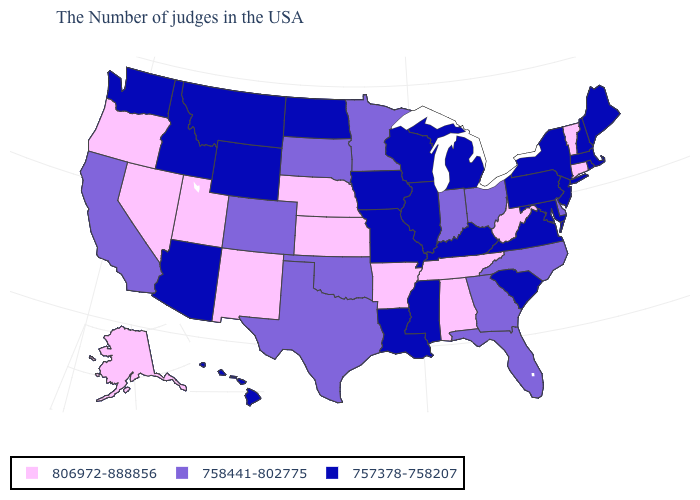Among the states that border Illinois , which have the highest value?
Quick response, please. Indiana. Among the states that border West Virginia , does Ohio have the highest value?
Quick response, please. Yes. Which states have the highest value in the USA?
Quick response, please. Vermont, Connecticut, West Virginia, Alabama, Tennessee, Arkansas, Kansas, Nebraska, New Mexico, Utah, Nevada, Oregon, Alaska. What is the lowest value in the USA?
Quick response, please. 757378-758207. What is the value of Alabama?
Quick response, please. 806972-888856. Name the states that have a value in the range 758441-802775?
Be succinct. Delaware, North Carolina, Ohio, Florida, Georgia, Indiana, Minnesota, Oklahoma, Texas, South Dakota, Colorado, California. Among the states that border New Jersey , does Pennsylvania have the lowest value?
Answer briefly. Yes. Which states have the lowest value in the USA?
Keep it brief. Maine, Massachusetts, Rhode Island, New Hampshire, New York, New Jersey, Maryland, Pennsylvania, Virginia, South Carolina, Michigan, Kentucky, Wisconsin, Illinois, Mississippi, Louisiana, Missouri, Iowa, North Dakota, Wyoming, Montana, Arizona, Idaho, Washington, Hawaii. What is the value of New Mexico?
Write a very short answer. 806972-888856. Which states hav the highest value in the South?
Give a very brief answer. West Virginia, Alabama, Tennessee, Arkansas. What is the value of Oklahoma?
Write a very short answer. 758441-802775. Which states hav the highest value in the MidWest?
Give a very brief answer. Kansas, Nebraska. Name the states that have a value in the range 757378-758207?
Keep it brief. Maine, Massachusetts, Rhode Island, New Hampshire, New York, New Jersey, Maryland, Pennsylvania, Virginia, South Carolina, Michigan, Kentucky, Wisconsin, Illinois, Mississippi, Louisiana, Missouri, Iowa, North Dakota, Wyoming, Montana, Arizona, Idaho, Washington, Hawaii. Which states hav the highest value in the MidWest?
Answer briefly. Kansas, Nebraska. Name the states that have a value in the range 806972-888856?
Quick response, please. Vermont, Connecticut, West Virginia, Alabama, Tennessee, Arkansas, Kansas, Nebraska, New Mexico, Utah, Nevada, Oregon, Alaska. 